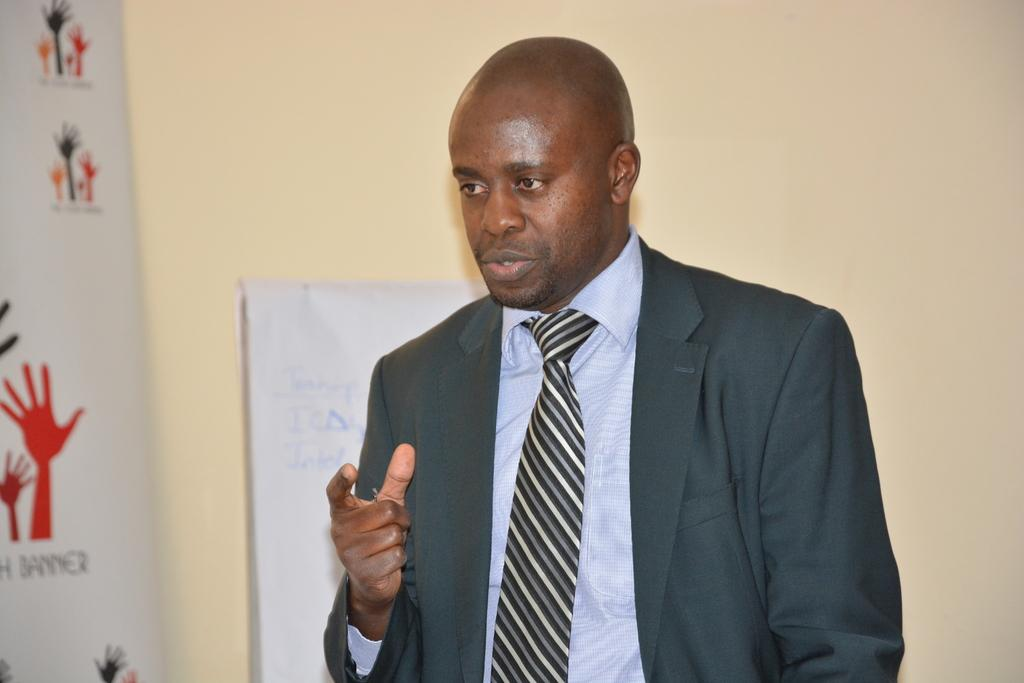What is the main subject of the image? There is a person in the image. What is the person wearing? The person is wearing a suit. What is the person doing in the image? The person is talking. What can be seen on the left side of the image? There is a banner with images on the left side of the image. What is visible in the background of the image? There is a wall and a poster in the background of the image. Can you tell me how many bees are sitting on the person's shoulder in the image? There are no bees present in the image. What type of clover is growing near the person in the image? There is no clover visible in the image. 